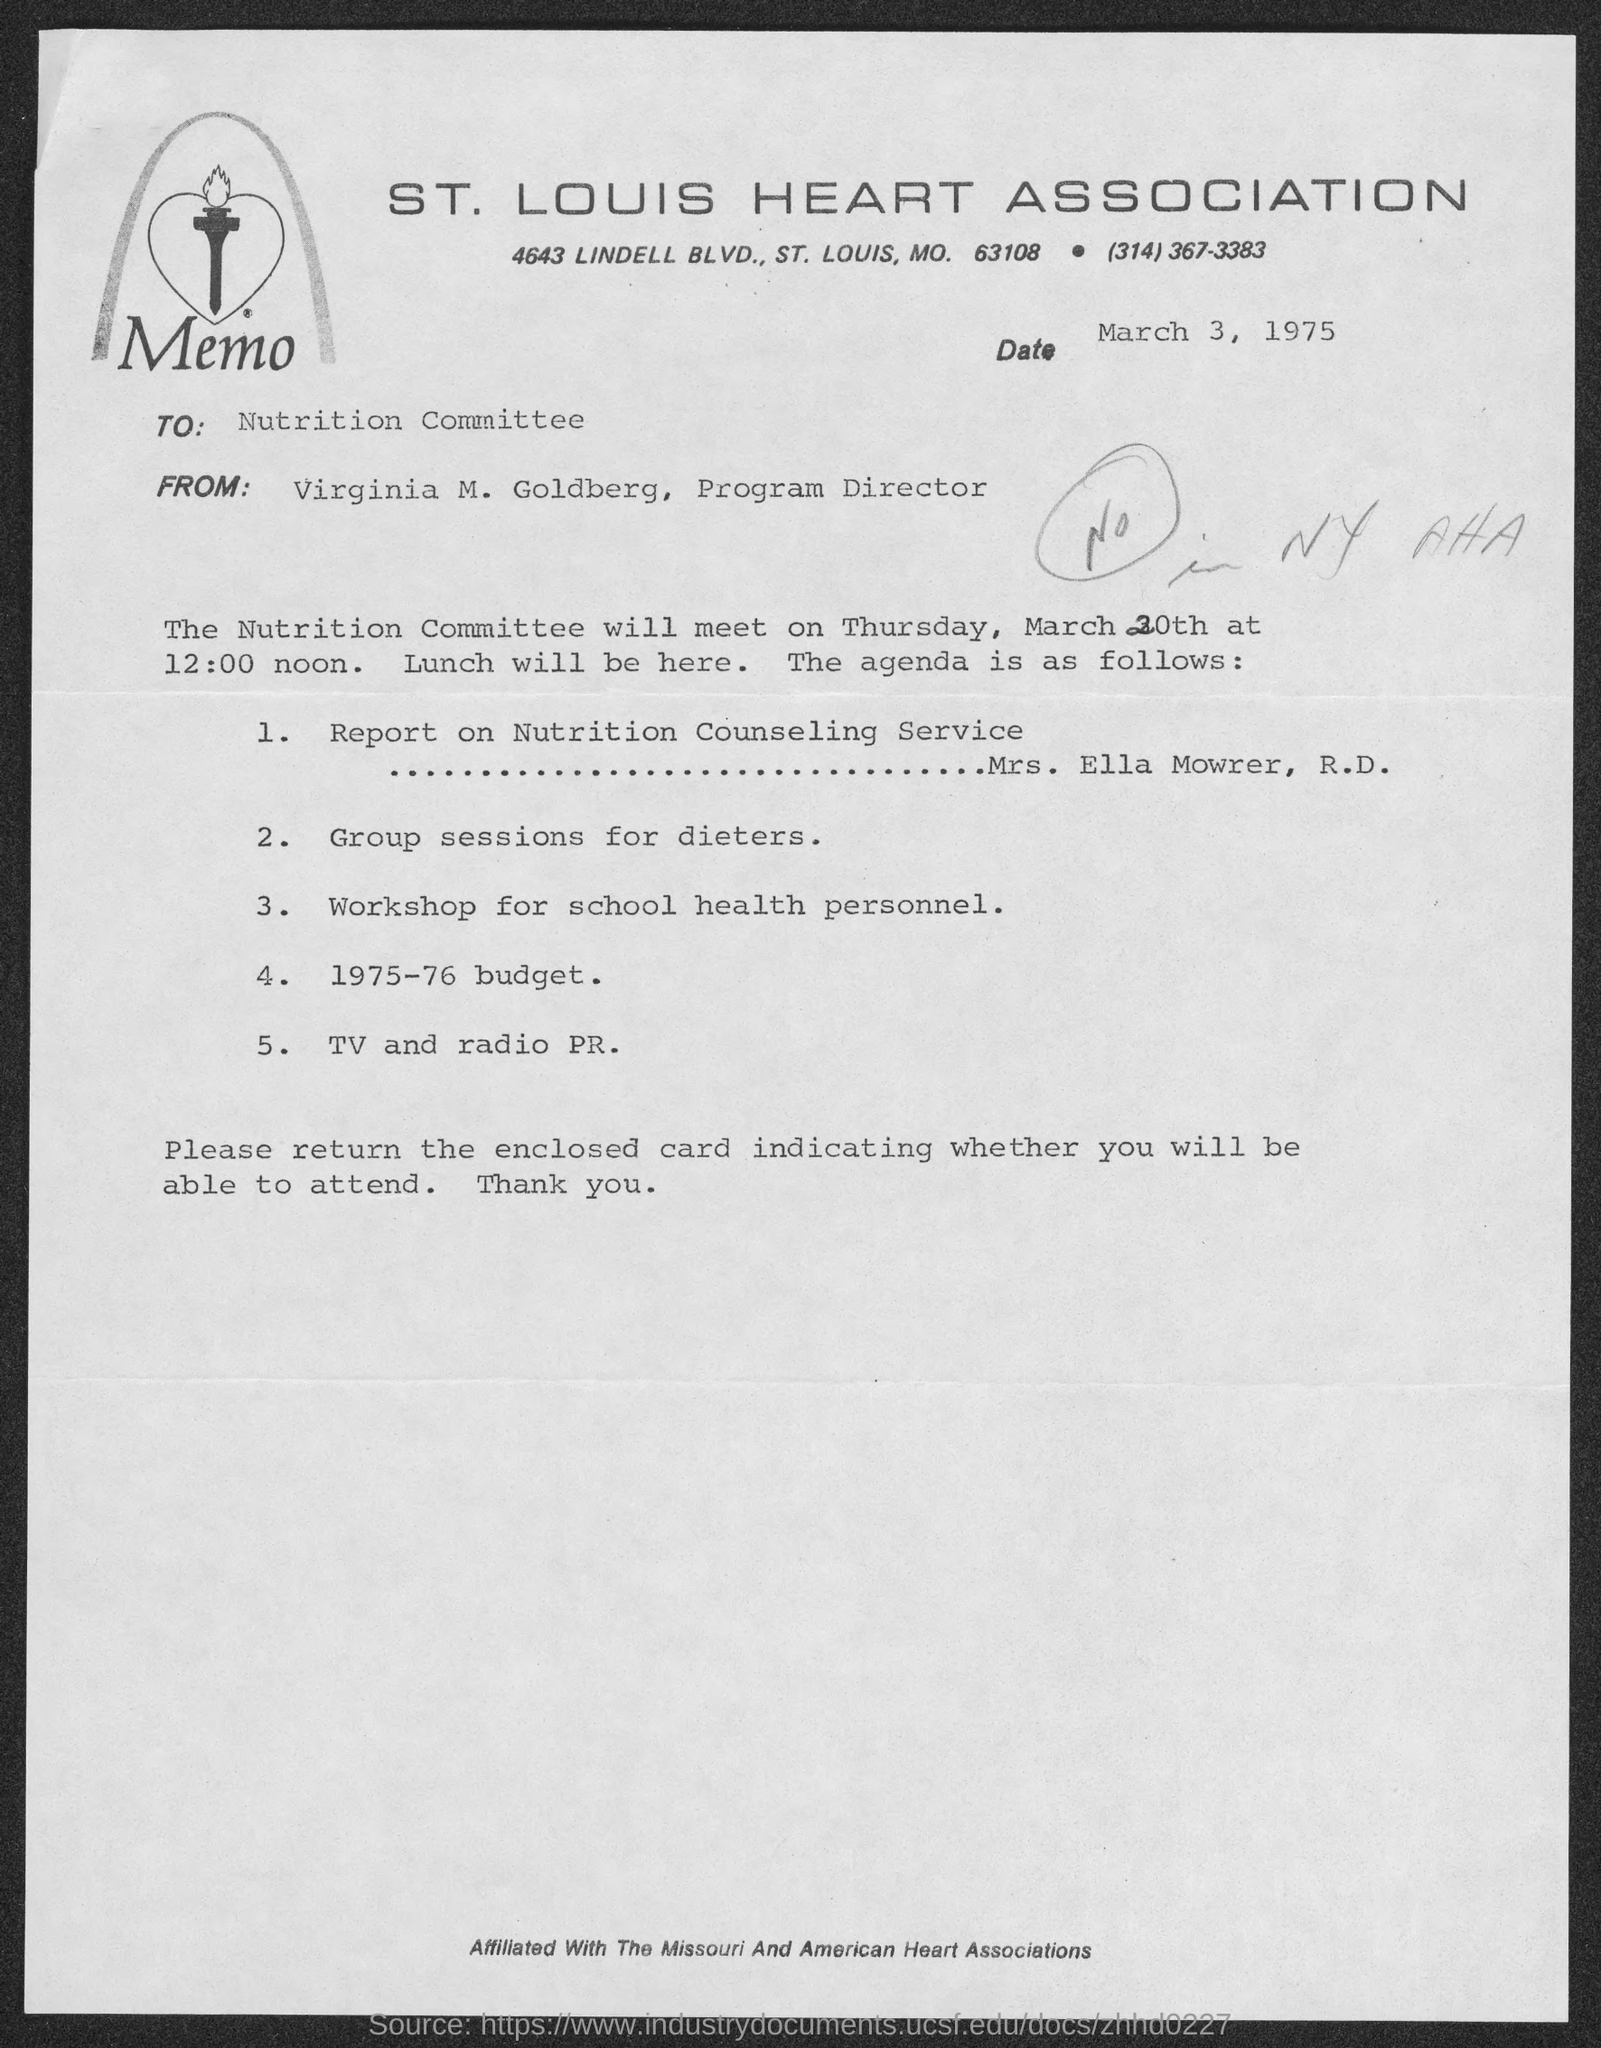List a handful of essential elements in this visual. The report on Nutrition Counseling Service will be presented by Mrs. Ella Mowrer, R.D., as stated in the agenda. The St. Louis Heart Association is mentioned in the letterhead. The memo is addressed to the Nutrition Committee. The sender of this memo is Virginia M. Goldberg. The issued date of this memo is March 3, 1975. 